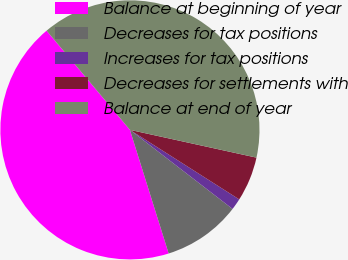<chart> <loc_0><loc_0><loc_500><loc_500><pie_chart><fcel>Balance at beginning of year<fcel>Decreases for tax positions<fcel>Increases for tax positions<fcel>Decreases for settlements with<fcel>Balance at end of year<nl><fcel>43.71%<fcel>9.72%<fcel>1.43%<fcel>5.58%<fcel>39.56%<nl></chart> 